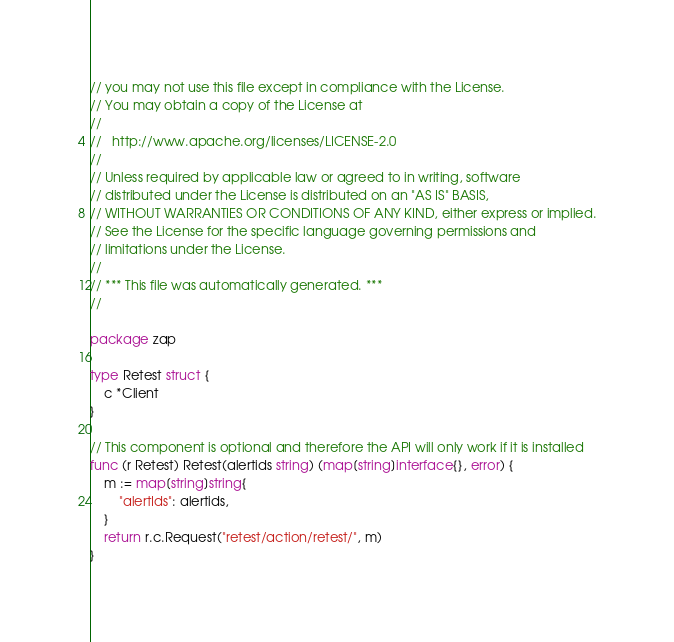Convert code to text. <code><loc_0><loc_0><loc_500><loc_500><_Go_>// you may not use this file except in compliance with the License.
// You may obtain a copy of the License at
//
//   http://www.apache.org/licenses/LICENSE-2.0
//
// Unless required by applicable law or agreed to in writing, software
// distributed under the License is distributed on an "AS IS" BASIS,
// WITHOUT WARRANTIES OR CONDITIONS OF ANY KIND, either express or implied.
// See the License for the specific language governing permissions and
// limitations under the License.
//
// *** This file was automatically generated. ***
//

package zap

type Retest struct {
	c *Client
}

// This component is optional and therefore the API will only work if it is installed
func (r Retest) Retest(alertids string) (map[string]interface{}, error) {
	m := map[string]string{
		"alertIds": alertids,
	}
	return r.c.Request("retest/action/retest/", m)
}
</code> 